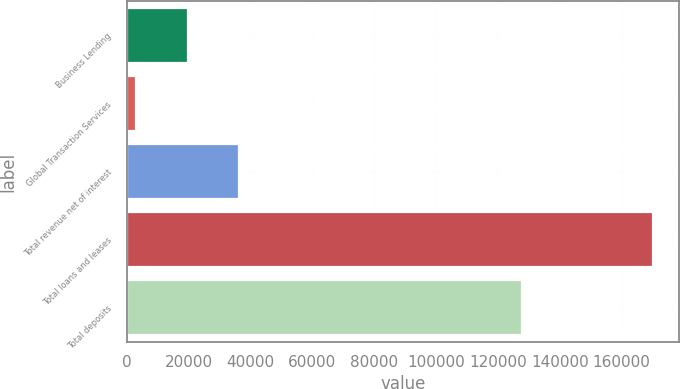Convert chart to OTSL. <chart><loc_0><loc_0><loc_500><loc_500><bar_chart><fcel>Business Lending<fcel>Global Transaction Services<fcel>Total revenue net of interest<fcel>Total loans and leases<fcel>Total deposits<nl><fcel>19725.4<fcel>3017<fcel>36433.8<fcel>170101<fcel>127720<nl></chart> 